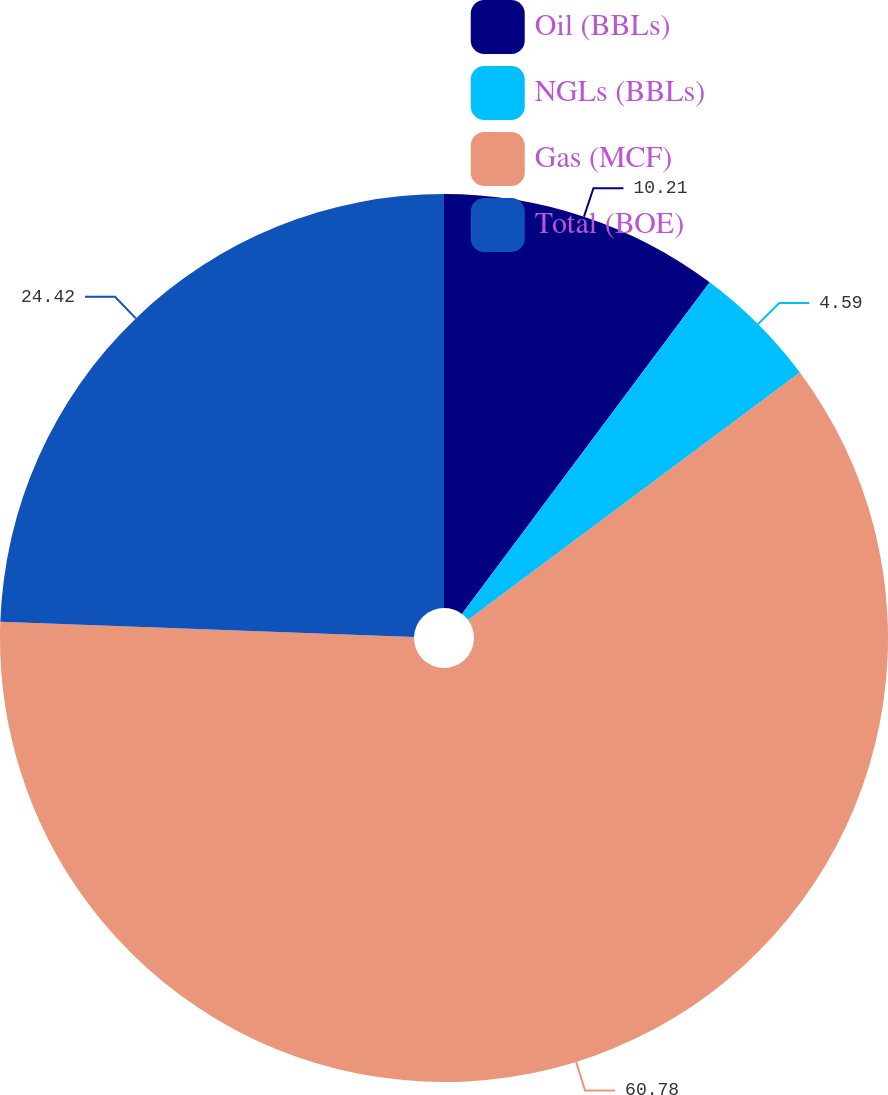<chart> <loc_0><loc_0><loc_500><loc_500><pie_chart><fcel>Oil (BBLs)<fcel>NGLs (BBLs)<fcel>Gas (MCF)<fcel>Total (BOE)<nl><fcel>10.21%<fcel>4.59%<fcel>60.78%<fcel>24.42%<nl></chart> 